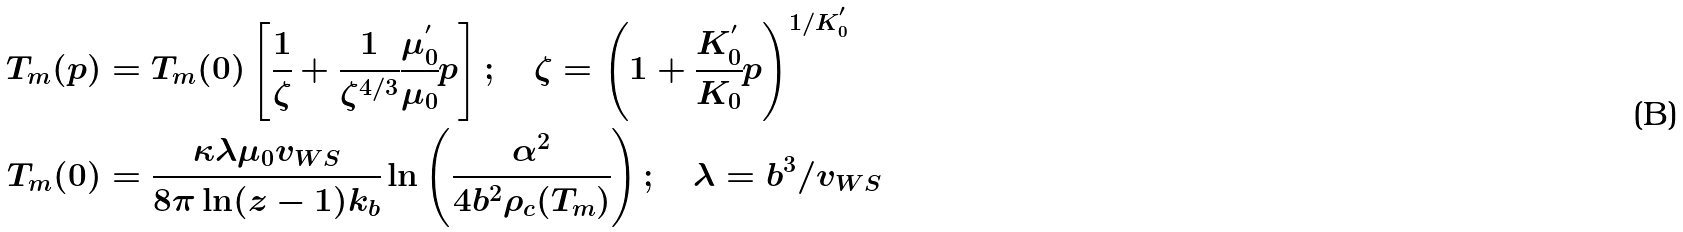<formula> <loc_0><loc_0><loc_500><loc_500>T _ { m } ( p ) & = T _ { m } ( 0 ) \left [ \cfrac { 1 } { \zeta } + \cfrac { 1 } { \zeta ^ { 4 / 3 } } \cfrac { \mu _ { 0 } ^ { ^ { \prime } } } { \mu _ { 0 } } p \right ] ; \quad \zeta = \left ( 1 + \cfrac { K _ { 0 } ^ { ^ { \prime } } } { K _ { 0 } } p \right ) ^ { 1 / K _ { 0 } ^ { ^ { \prime } } } \\ T _ { m } ( 0 ) & = \cfrac { \kappa \lambda \mu _ { 0 } v _ { W S } } { 8 \pi \ln ( z - 1 ) k _ { b } } \ln \left ( \cfrac { \alpha ^ { 2 } } { 4 b ^ { 2 } \rho _ { c } ( T _ { m } ) } \right ) ; \quad \lambda = b ^ { 3 } / v _ { W S }</formula> 